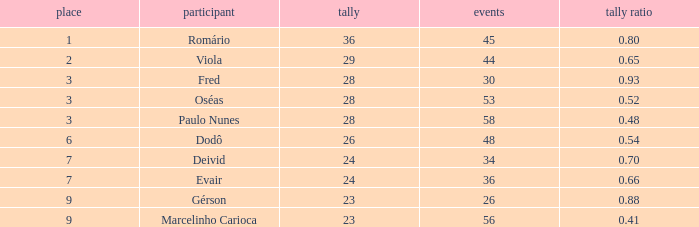How many goals have a goal ration less than 0.8 with 56 games? 1.0. 